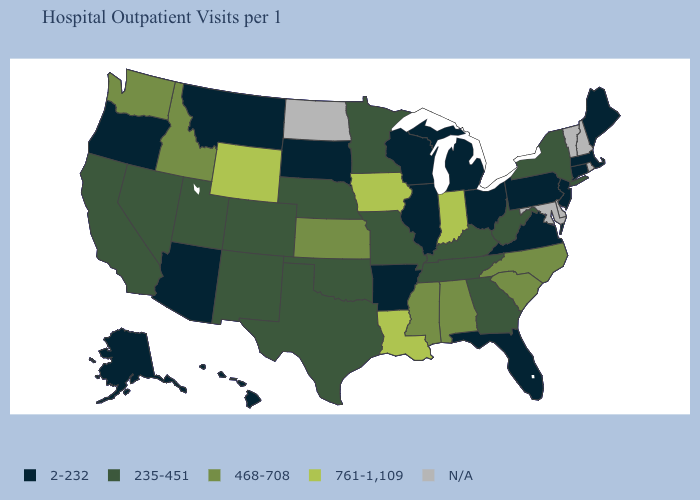Name the states that have a value in the range 468-708?
Keep it brief. Alabama, Idaho, Kansas, Mississippi, North Carolina, South Carolina, Washington. Which states hav the highest value in the South?
Give a very brief answer. Louisiana. Which states have the highest value in the USA?
Be succinct. Indiana, Iowa, Louisiana, Wyoming. What is the value of Mississippi?
Short answer required. 468-708. What is the value of Illinois?
Give a very brief answer. 2-232. What is the value of Connecticut?
Answer briefly. 2-232. What is the highest value in the USA?
Concise answer only. 761-1,109. What is the value of Oklahoma?
Answer briefly. 235-451. What is the value of Louisiana?
Answer briefly. 761-1,109. Which states have the lowest value in the USA?
Write a very short answer. Alaska, Arizona, Arkansas, Connecticut, Florida, Hawaii, Illinois, Maine, Massachusetts, Michigan, Montana, New Jersey, Ohio, Oregon, Pennsylvania, South Dakota, Virginia, Wisconsin. What is the value of Alaska?
Answer briefly. 2-232. Name the states that have a value in the range 235-451?
Answer briefly. California, Colorado, Georgia, Kentucky, Minnesota, Missouri, Nebraska, Nevada, New Mexico, New York, Oklahoma, Tennessee, Texas, Utah, West Virginia. Name the states that have a value in the range 761-1,109?
Quick response, please. Indiana, Iowa, Louisiana, Wyoming. What is the value of South Dakota?
Concise answer only. 2-232. 